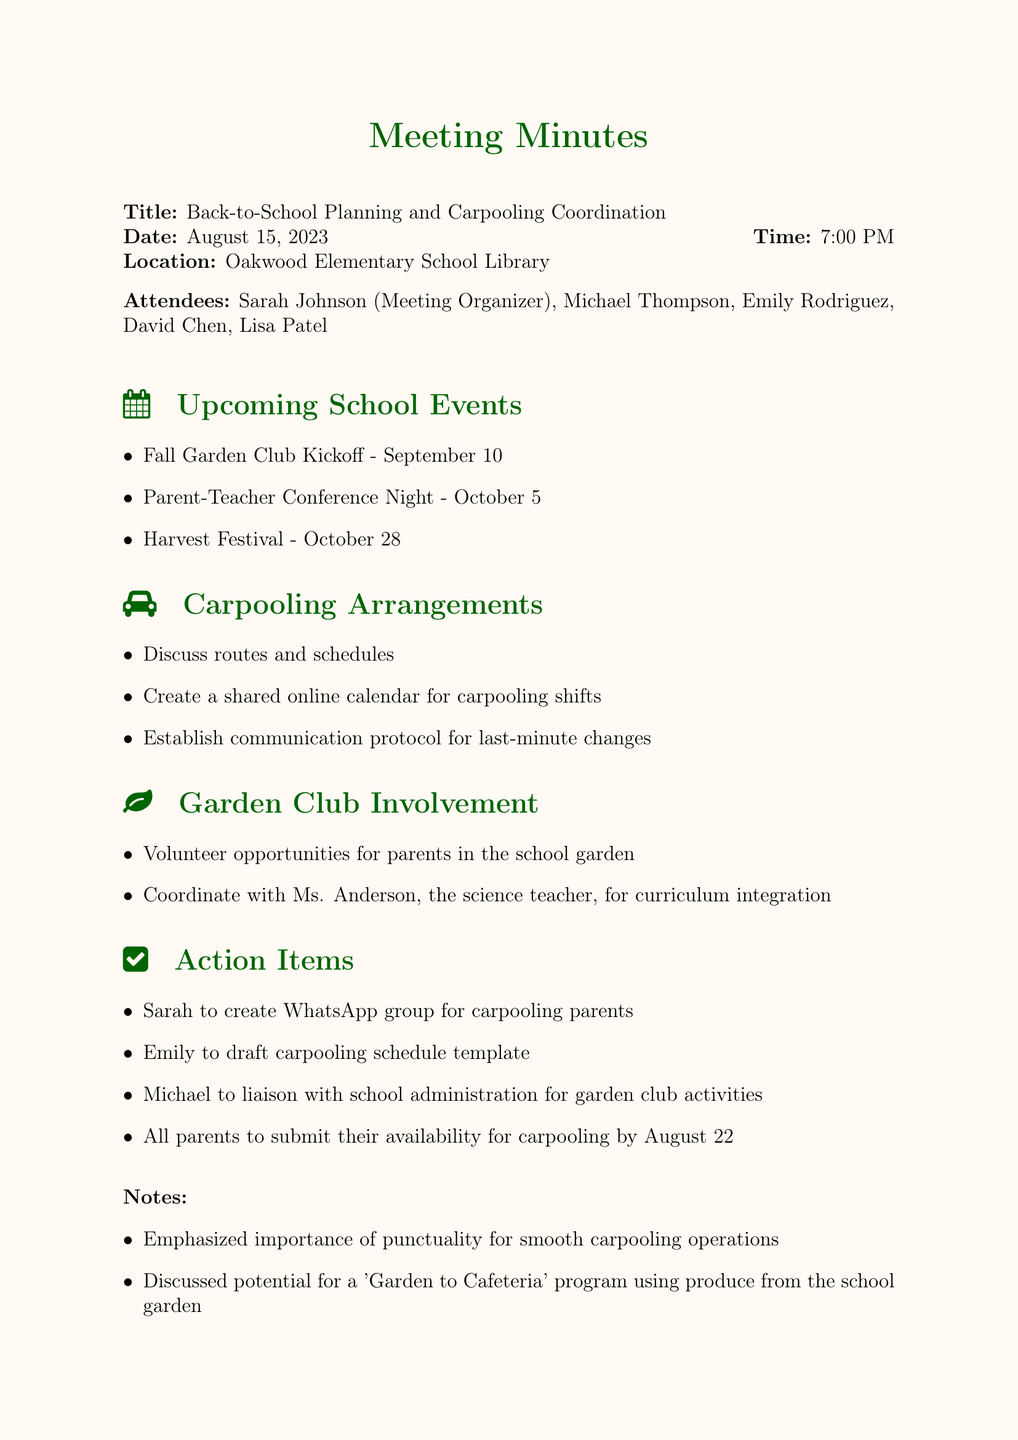What is the title of the meeting? The title of the meeting is explicitly stated at the beginning of the document, which is "Back-to-School Planning and Carpooling Coordination."
Answer: Back-to-School Planning and Carpooling Coordination When is the Parent-Teacher Conference Night scheduled? The date for the Parent-Teacher Conference Night can be found in the agenda under Upcoming School Events, which is October 5.
Answer: October 5 Who is responsible for creating the WhatsApp group for carpooling parents? The document lists Sarah as the person assigned to create the WhatsApp group in the Action Items section.
Answer: Sarah What is the deadline for parents to submit their availability for carpooling? The deadline is mentioned in the Action Items and is set for August 22.
Answer: August 22 What are the three main topics discussed during the meeting? The main topics can be summarized from the agenda items, which are "Upcoming School Events," "Carpooling Arrangements," and "Garden Club Involvement."
Answer: Upcoming School Events, Carpooling Arrangements, Garden Club Involvement How many attendees were present at the meeting? The list of attendees indicates that there were five parents present at the meeting as listed in the document.
Answer: Five What volunteer opportunities were discussed for parents? The document mentions that there are volunteer opportunities for parents specifically in the school garden under the Garden Club Involvement section.
Answer: School garden What communication method was established for last-minute changes in carpooling? The document states that a communication protocol for last-minute changes was discussed in the Carpooling Arrangements section.
Answer: Communication protocol What is emphasized as important for smooth carpooling operations? The notes section of the document highlights the importance of punctuality for the success of carpooling arrangements.
Answer: Punctuality 